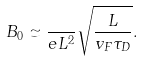Convert formula to latex. <formula><loc_0><loc_0><loc_500><loc_500>B _ { 0 } \simeq \frac { } { e L ^ { 2 } } \sqrt { \frac { L } { v _ { F } \tau _ { D } } } .</formula> 